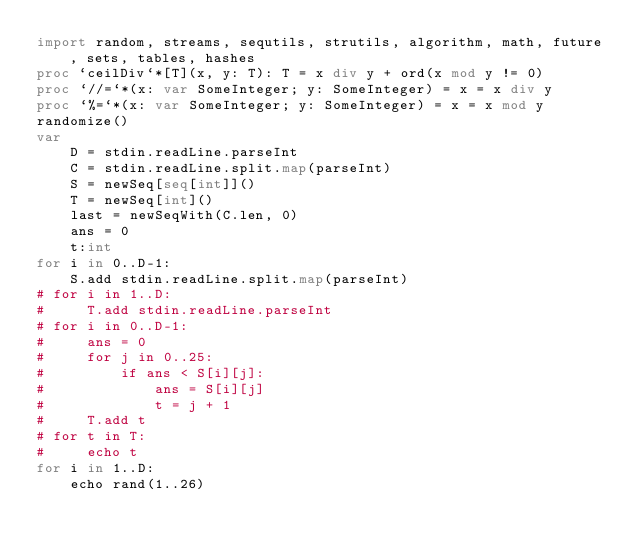<code> <loc_0><loc_0><loc_500><loc_500><_Nim_>import random, streams, sequtils, strutils, algorithm, math, future, sets, tables, hashes
proc `ceilDiv`*[T](x, y: T): T = x div y + ord(x mod y != 0)
proc `//=`*(x: var SomeInteger; y: SomeInteger) = x = x div y
proc `%=`*(x: var SomeInteger; y: SomeInteger) = x = x mod y
randomize()
var
    D = stdin.readLine.parseInt
    C = stdin.readLine.split.map(parseInt)
    S = newSeq[seq[int]]()
    T = newSeq[int]()
    last = newSeqWith(C.len, 0)
    ans = 0
    t:int
for i in 0..D-1:
    S.add stdin.readLine.split.map(parseInt)
# for i in 1..D:
#     T.add stdin.readLine.parseInt
# for i in 0..D-1:
#     ans = 0
#     for j in 0..25:
#         if ans < S[i][j]:
#             ans = S[i][j]
#             t = j + 1
#     T.add t
# for t in T:
#     echo t
for i in 1..D:
    echo rand(1..26)</code> 